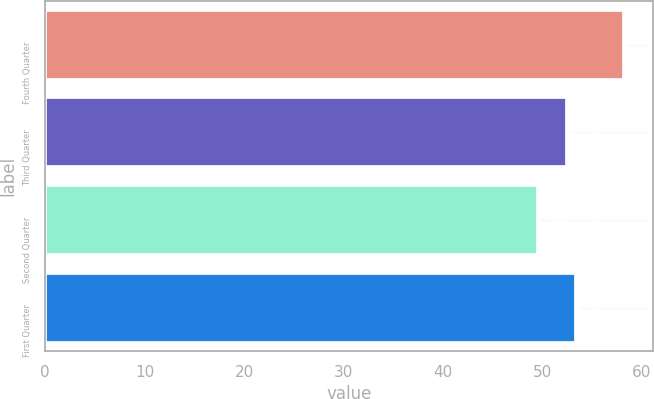<chart> <loc_0><loc_0><loc_500><loc_500><bar_chart><fcel>Fourth Quarter<fcel>Third Quarter<fcel>Second Quarter<fcel>First Quarter<nl><fcel>58.2<fcel>52.5<fcel>49.57<fcel>53.36<nl></chart> 